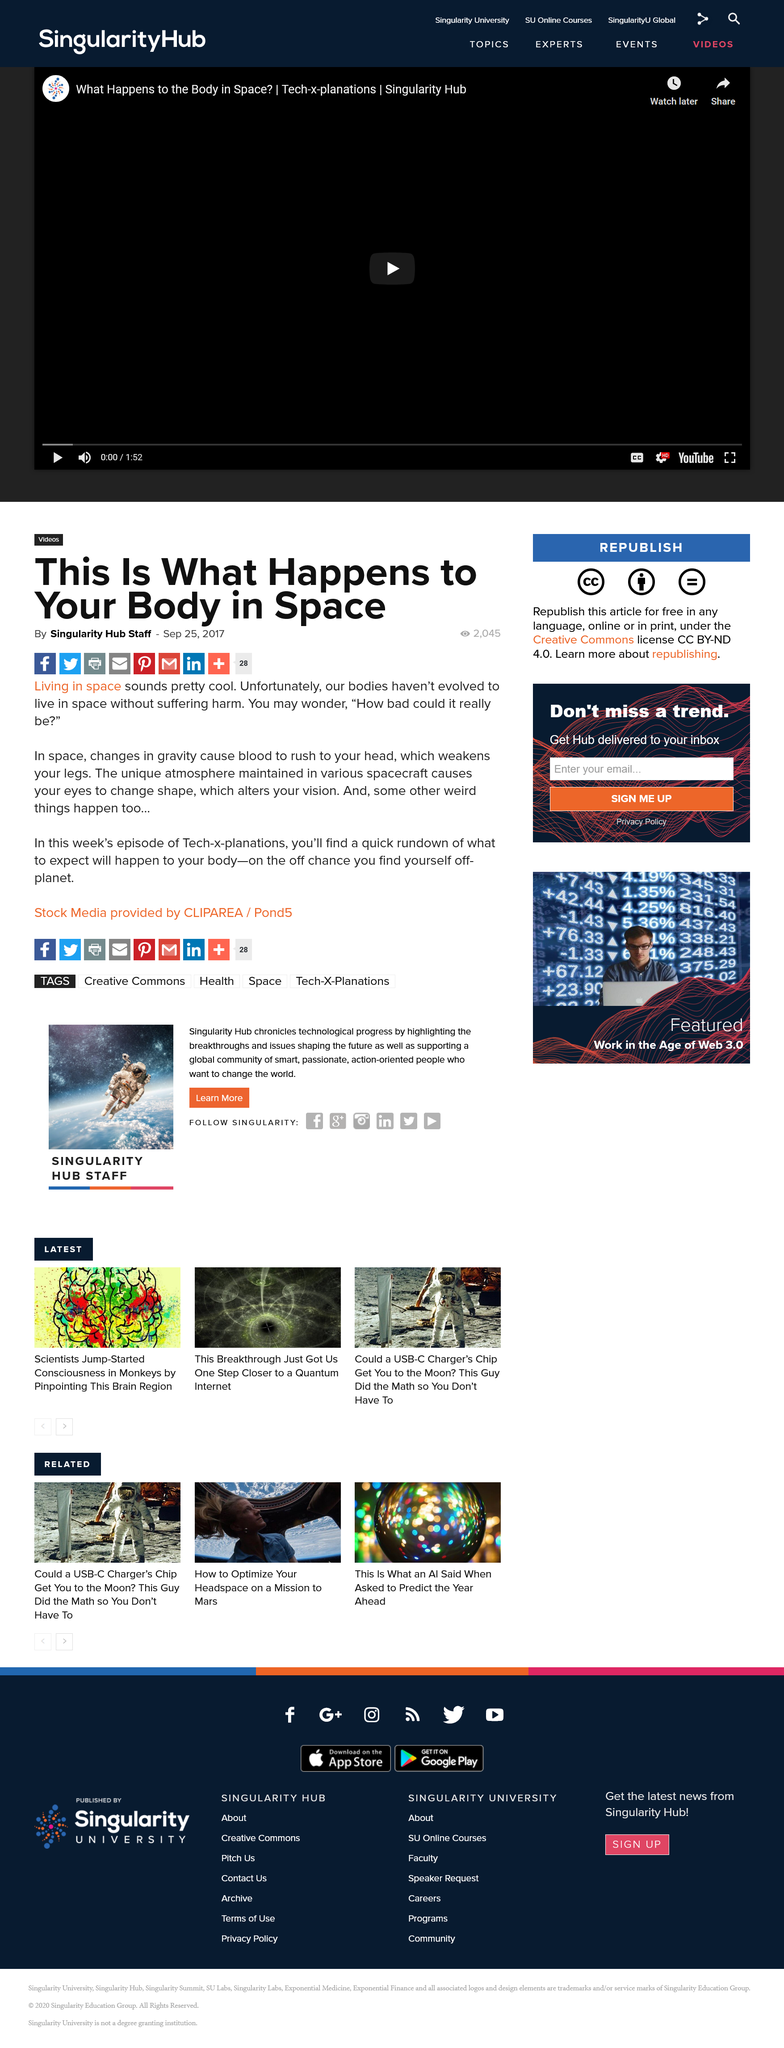Outline some significant characteristics in this image. The article "This Is What Happens to Your Body in Space" was published on September 25th, 2017. Singularity Hub Staff is the author of this information. 